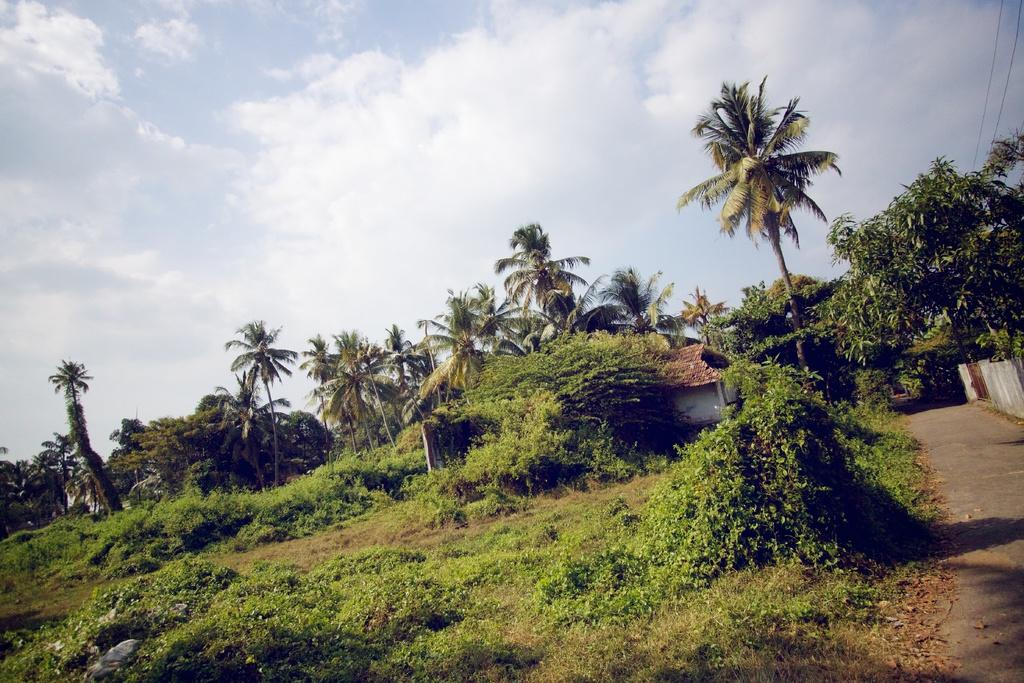What type of view is shown in the image? The image is an outside view. What can be seen on the right side of the image? There is a road on the right side of the image. What type of vegetation is present in the image? There are many plants and trees in the image. What type of structures can be seen in the image? There are houses in the image. What is visible at the top of the image? The sky is visible at the top of the image. What can be observed in the sky? Clouds are present in the sky. Where is the sweater hanging in the image? There is no sweater present in the image. What time does the clock show in the image? There is no clock present in the image. 